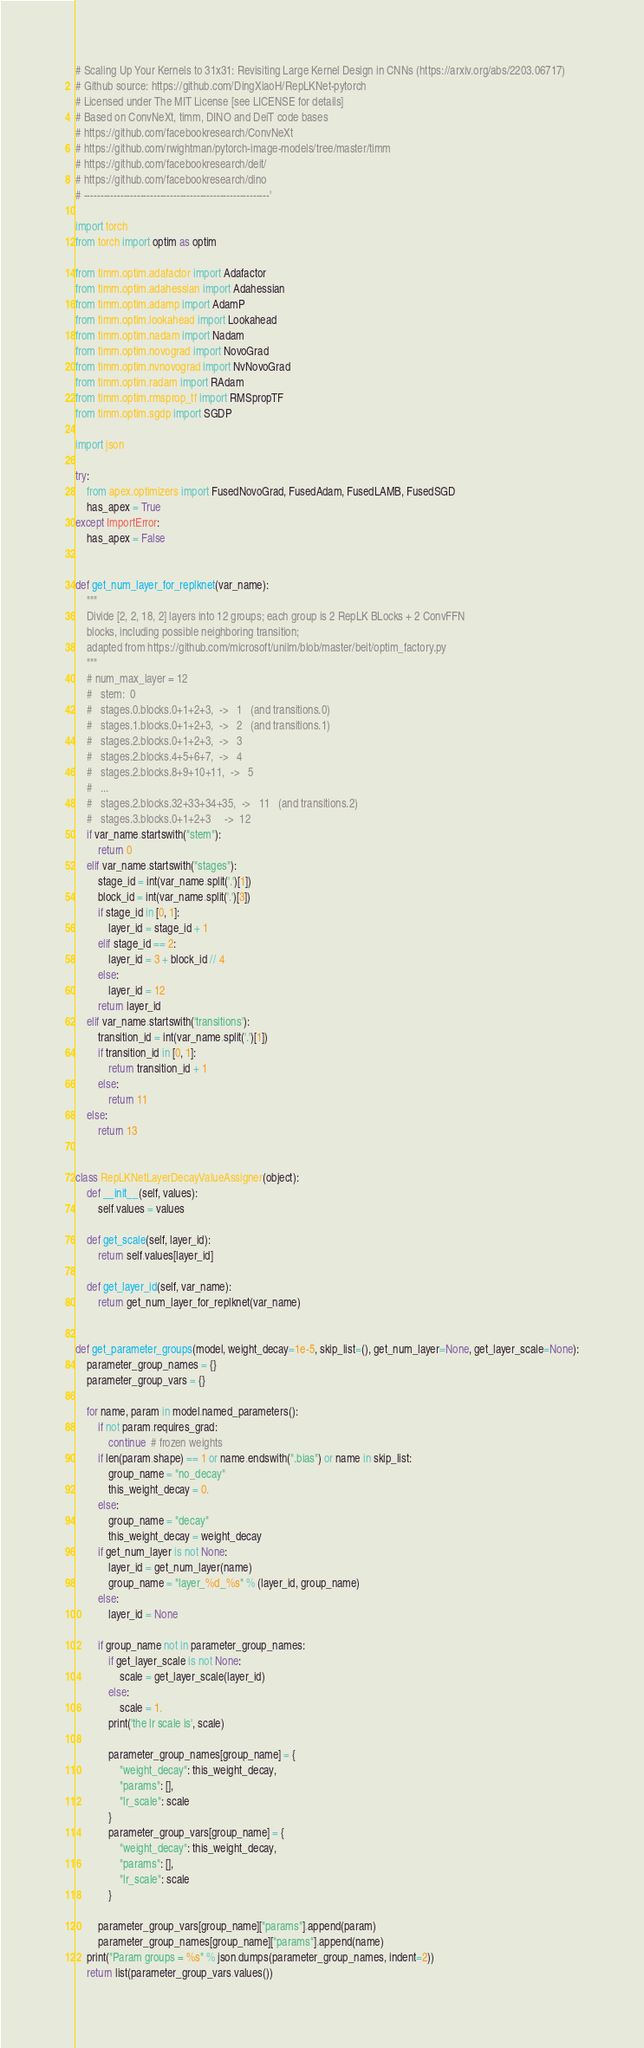<code> <loc_0><loc_0><loc_500><loc_500><_Python_># Scaling Up Your Kernels to 31x31: Revisiting Large Kernel Design in CNNs (https://arxiv.org/abs/2203.06717)
# Github source: https://github.com/DingXiaoH/RepLKNet-pytorch
# Licensed under The MIT License [see LICENSE for details]
# Based on ConvNeXt, timm, DINO and DeiT code bases
# https://github.com/facebookresearch/ConvNeXt
# https://github.com/rwightman/pytorch-image-models/tree/master/timm
# https://github.com/facebookresearch/deit/
# https://github.com/facebookresearch/dino
# --------------------------------------------------------'

import torch
from torch import optim as optim

from timm.optim.adafactor import Adafactor
from timm.optim.adahessian import Adahessian
from timm.optim.adamp import AdamP
from timm.optim.lookahead import Lookahead
from timm.optim.nadam import Nadam
from timm.optim.novograd import NovoGrad
from timm.optim.nvnovograd import NvNovoGrad
from timm.optim.radam import RAdam
from timm.optim.rmsprop_tf import RMSpropTF
from timm.optim.sgdp import SGDP

import json

try:
    from apex.optimizers import FusedNovoGrad, FusedAdam, FusedLAMB, FusedSGD
    has_apex = True
except ImportError:
    has_apex = False


def get_num_layer_for_replknet(var_name):
    """
    Divide [2, 2, 18, 2] layers into 12 groups; each group is 2 RepLK BLocks + 2 ConvFFN
    blocks, including possible neighboring transition;
    adapted from https://github.com/microsoft/unilm/blob/master/beit/optim_factory.py
    """
    # num_max_layer = 12
    #   stem:  0
    #   stages.0.blocks.0+1+2+3,  ->   1   (and transitions.0)
    #   stages.1.blocks.0+1+2+3,  ->   2   (and transitions.1)
    #   stages.2.blocks.0+1+2+3,  ->   3
    #   stages.2.blocks.4+5+6+7,  ->   4
    #   stages.2.blocks.8+9+10+11,  ->   5
    #   ...
    #   stages.2.blocks.32+33+34+35,  ->   11   (and transitions.2)
    #   stages.3.blocks.0+1+2+3     ->  12
    if var_name.startswith("stem"):
        return 0
    elif var_name.startswith("stages"):
        stage_id = int(var_name.split('.')[1])
        block_id = int(var_name.split('.')[3])
        if stage_id in [0, 1]:
            layer_id = stage_id + 1
        elif stage_id == 2:
            layer_id = 3 + block_id // 4
        else:
            layer_id = 12
        return layer_id
    elif var_name.startswith('transitions'):
        transition_id = int(var_name.split('.')[1])
        if transition_id in [0, 1]:
            return transition_id + 1
        else:
            return 11
    else:
        return 13


class RepLKNetLayerDecayValueAssigner(object):
    def __init__(self, values):
        self.values = values

    def get_scale(self, layer_id):
        return self.values[layer_id]

    def get_layer_id(self, var_name):
        return get_num_layer_for_replknet(var_name)


def get_parameter_groups(model, weight_decay=1e-5, skip_list=(), get_num_layer=None, get_layer_scale=None):
    parameter_group_names = {}
    parameter_group_vars = {}

    for name, param in model.named_parameters():
        if not param.requires_grad:
            continue  # frozen weights
        if len(param.shape) == 1 or name.endswith(".bias") or name in skip_list:
            group_name = "no_decay"
            this_weight_decay = 0.
        else:
            group_name = "decay"
            this_weight_decay = weight_decay
        if get_num_layer is not None:
            layer_id = get_num_layer(name)
            group_name = "layer_%d_%s" % (layer_id, group_name)
        else:
            layer_id = None

        if group_name not in parameter_group_names:
            if get_layer_scale is not None:
                scale = get_layer_scale(layer_id)
            else:
                scale = 1.
            print('the lr scale is', scale)

            parameter_group_names[group_name] = {
                "weight_decay": this_weight_decay,
                "params": [],
                "lr_scale": scale
            }
            parameter_group_vars[group_name] = {
                "weight_decay": this_weight_decay,
                "params": [],
                "lr_scale": scale
            }

        parameter_group_vars[group_name]["params"].append(param)
        parameter_group_names[group_name]["params"].append(name)
    print("Param groups = %s" % json.dumps(parameter_group_names, indent=2))
    return list(parameter_group_vars.values())

</code> 